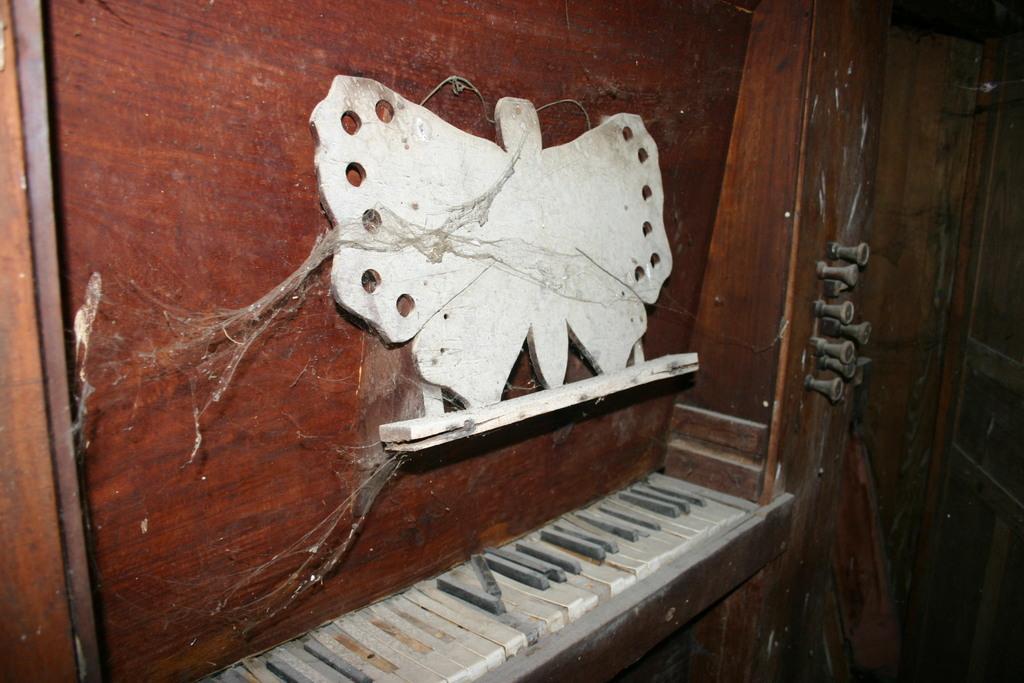Describe this image in one or two sentences. In this image we have a wooden frame in the shape of the butterfly fixed to the wall and down we have a piano keys. 